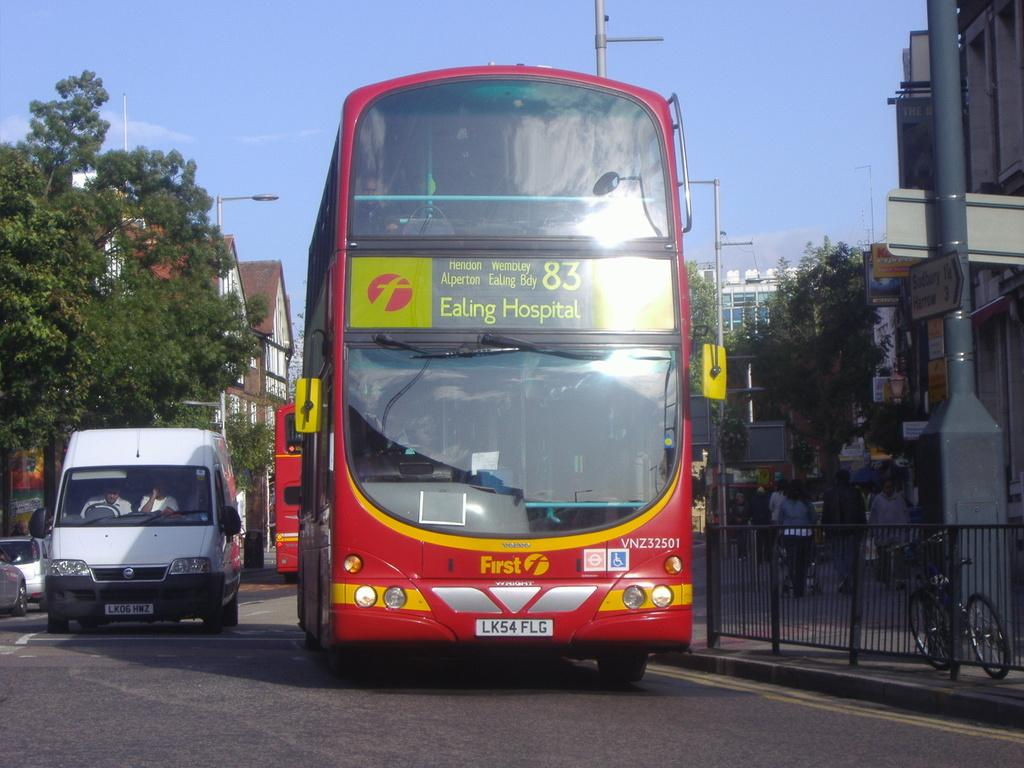<image>
Render a clear and concise summary of the photo. the word ealing on the front of a bus 